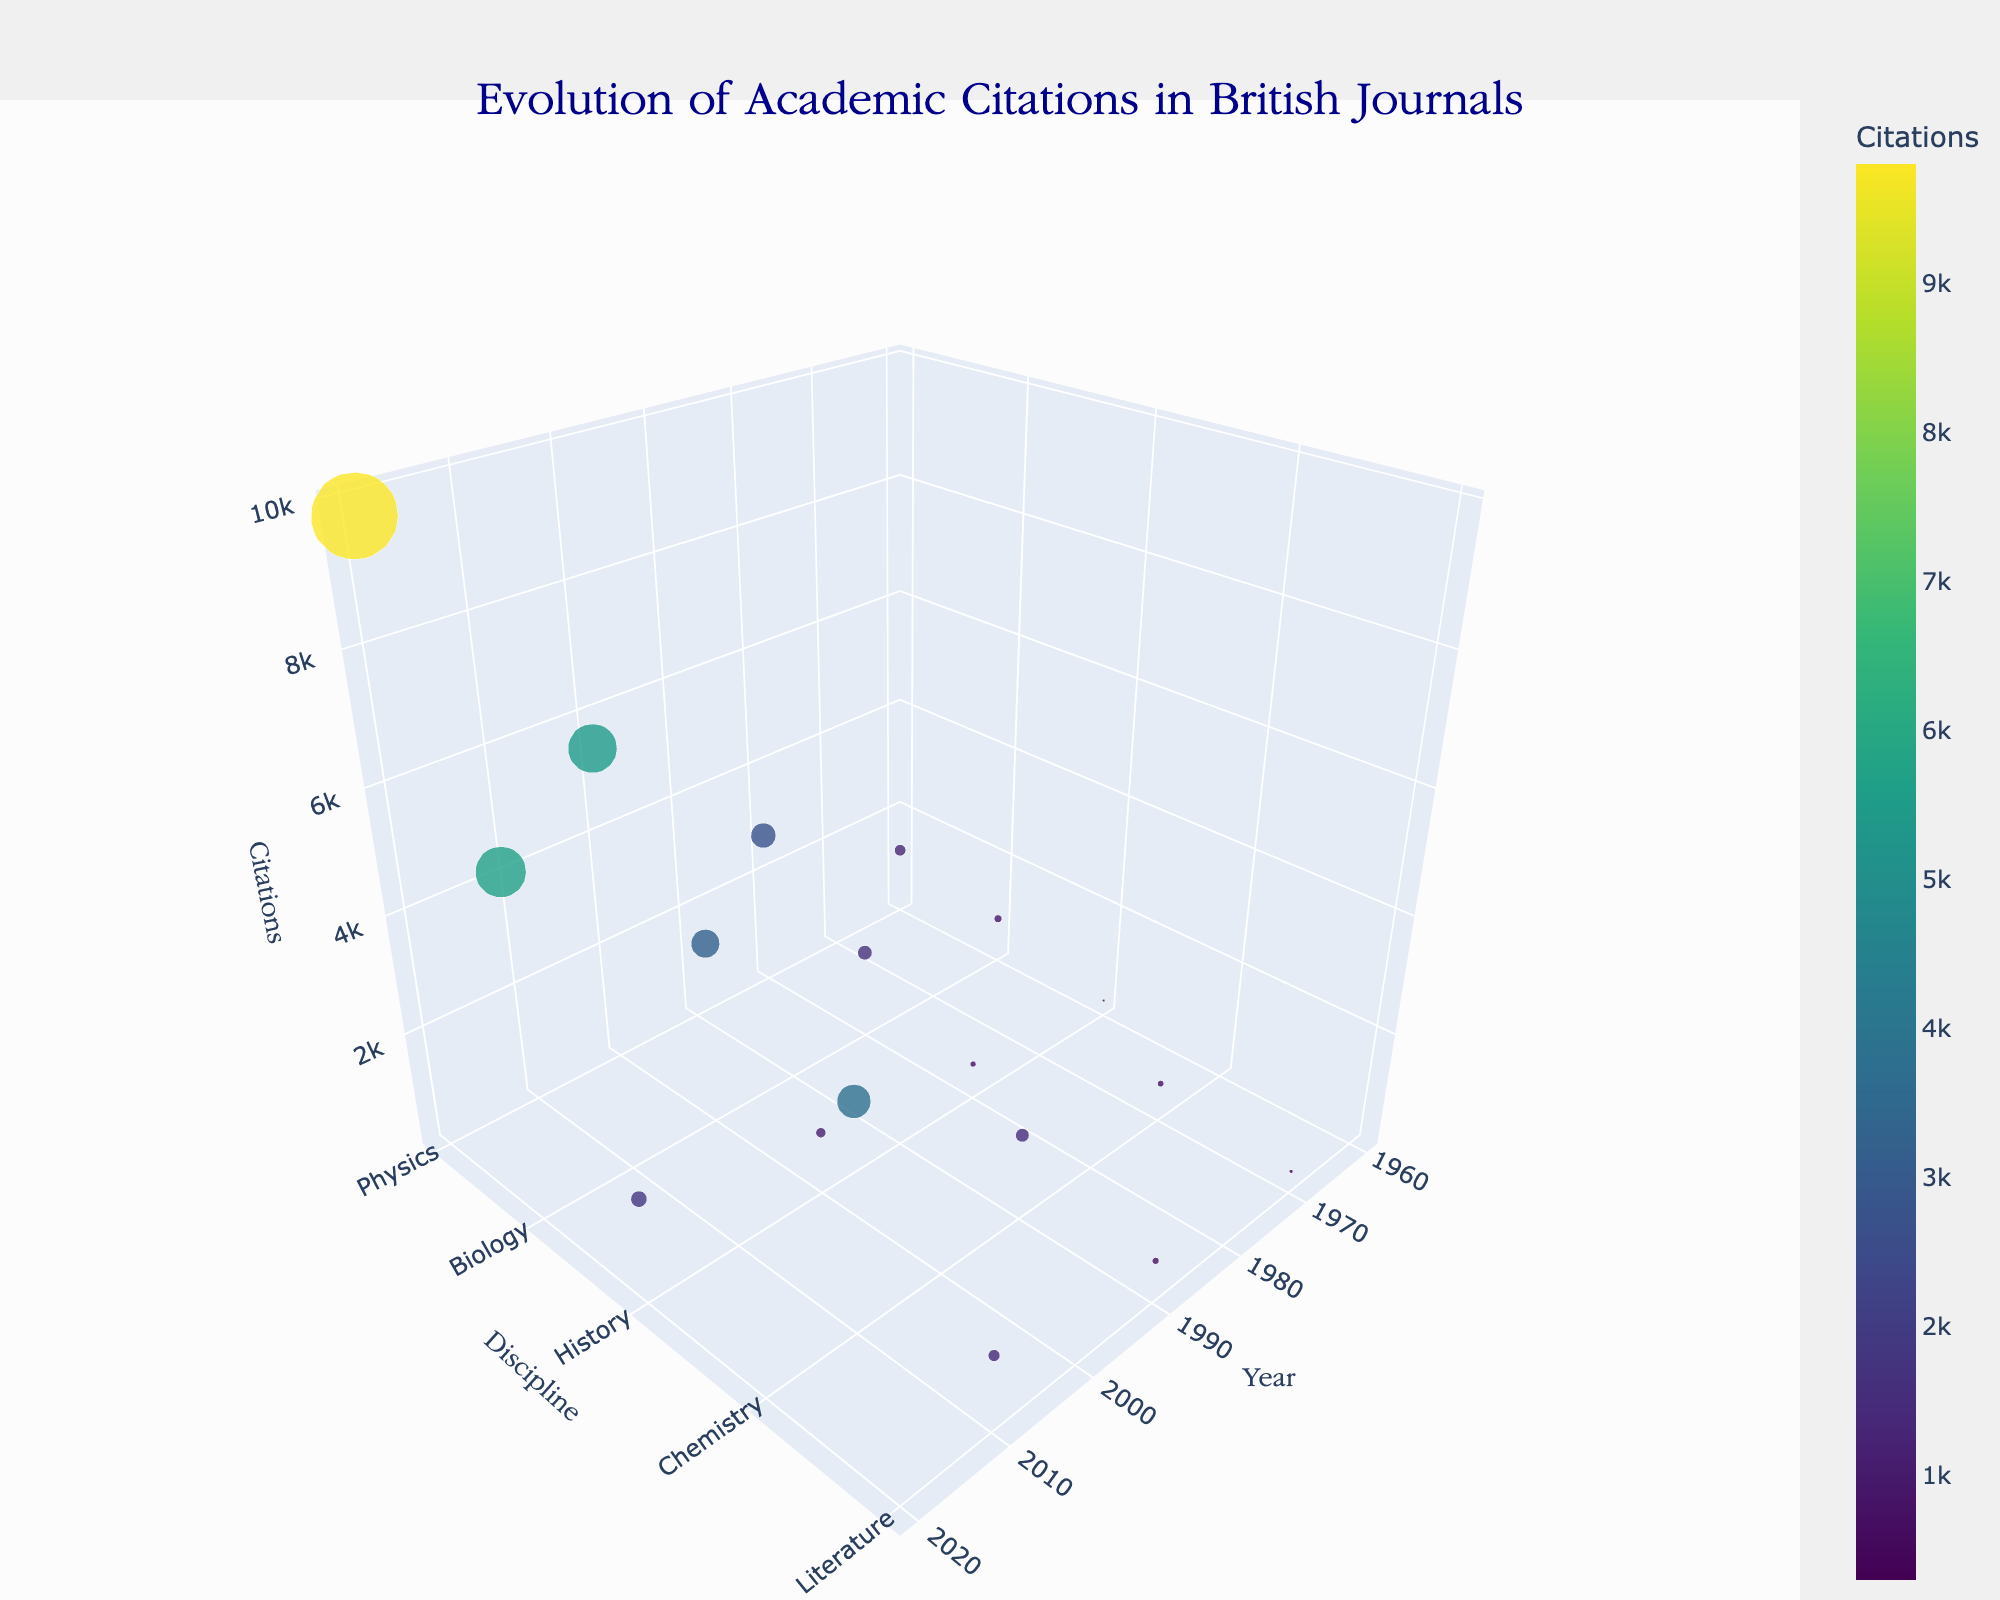What's the title of the figure? The title is located at the top of the plot. It is set to be very prominent and central. The title uses the Garamond font, colored dark blue.
Answer: Evolution of Academic Citations in British Journals What disciplines are represented in the year 1980? To determine the disciplines for the year 1980, look at the x-axis (Year) and find 1980. Then check the corresponding y-axis (Discipline) values at that point.
Answer: Physics, Biology, History Which discipline had the highest number of citations in 2020? Find the year 2020 on the x-axis. Then, observe the z-axis values (Citations) and identify which discipline on the y-axis corresponds to the highest point.
Answer: Physics Compare the number of citations for Physics in 2000 and 2020. By how much did it increase? Locate the year 2000 and find the Science discipline 'Physics' on the y-axis. Note the z-axis (Citations) value. Repeat for the year 2020. Finally, subtract the 2000 value from the 2020 value to find the increase.
Answer: 4300 Which journal had 850 citations in 1960? Locate the year 1960 on the x-axis, then check the z-axis to find where the citations count is 850. The journal name is displayed with hover information.
Answer: Journal of Ecology How did the citations for the Journal of Ecology change from 1960 to 2020? First, find the year 1960 on the x-axis and note the citations value for the Journal of Ecology. Repeat for the year 2020. Calculate the difference to understand the change.
Answer: Increased by 4850 What is the relationship between the number of citations in Literature and Chemistry in 2010? Which one is higher? For the year 2010, find the data points for Literature and Chemistry on the y-axis and compare their z-axis (Citations) values.
Answer: Chemistry Which discipline shows a consistent increase in citations across all decades? Observe the z-axis values for each discipline separately across the years. Look for a discipline where citations steadily rise in each subsequent decade.
Answer: Physics Does History have more citations in 2000 or in 2020? Compare the z-axis (Citations) value for the discipline 'History' in the years 2000 and 2020 by locating these years on the x-axis.
Answer: 2020 Is the average number of citations for Literature in the two recorded years (1990 and 2010) greater than 1000? Calculate the average by summing the citations in the two years (1990: 750; 2010: 1300) and then dividing by 2. Compare the result to 1000.
Answer: Yes 